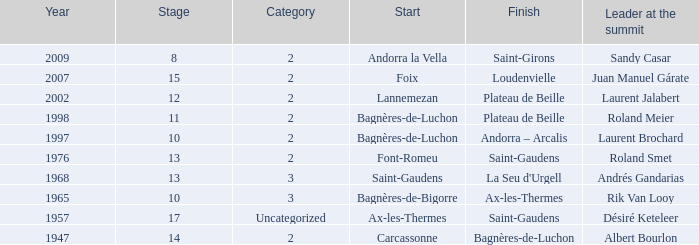Give the Finish for years after 2007. Saint-Girons. 